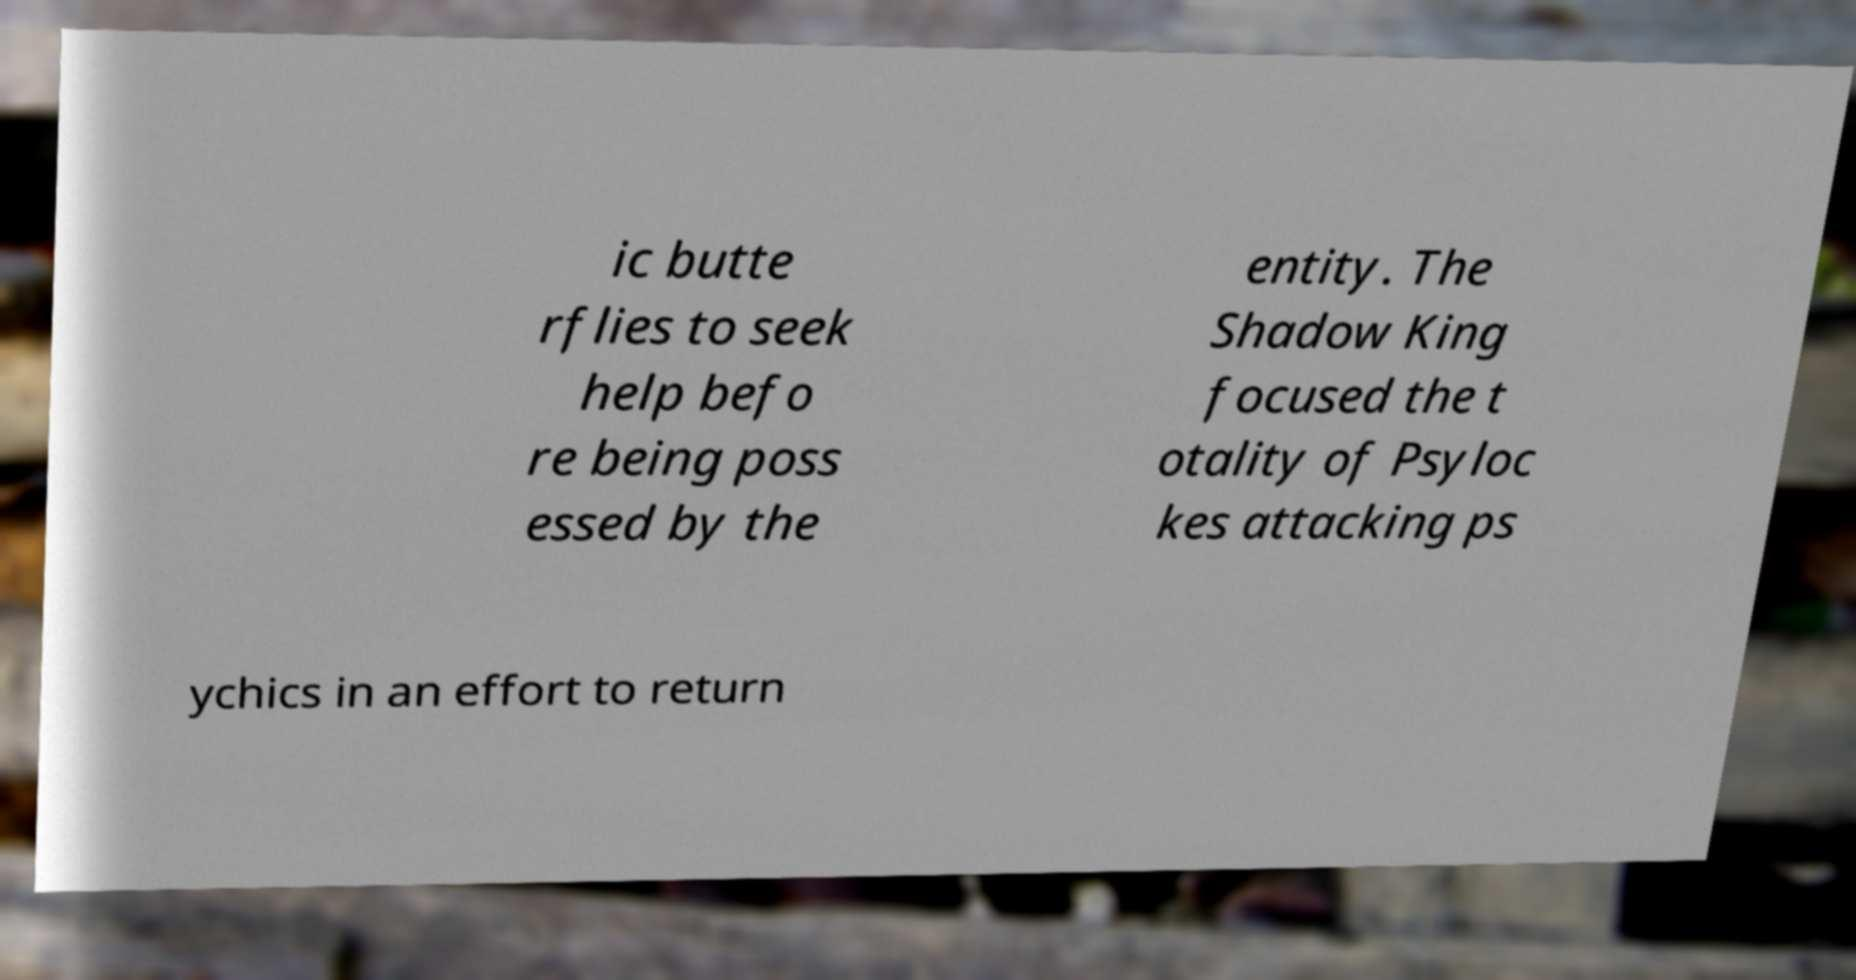What messages or text are displayed in this image? I need them in a readable, typed format. ic butte rflies to seek help befo re being poss essed by the entity. The Shadow King focused the t otality of Psyloc kes attacking ps ychics in an effort to return 